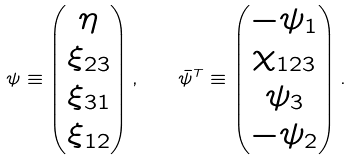<formula> <loc_0><loc_0><loc_500><loc_500>\psi \equiv \left ( \begin{matrix} \eta \\ \xi _ { 2 3 } \\ \xi _ { 3 1 } \\ \xi _ { 1 2 } \end{matrix} \right ) , \quad \bar { \psi } ^ { T } \equiv \left ( \begin{matrix} - \psi _ { 1 } \\ \chi _ { 1 2 3 } \\ \psi _ { 3 } \\ - \psi _ { 2 } \end{matrix} \right ) .</formula> 